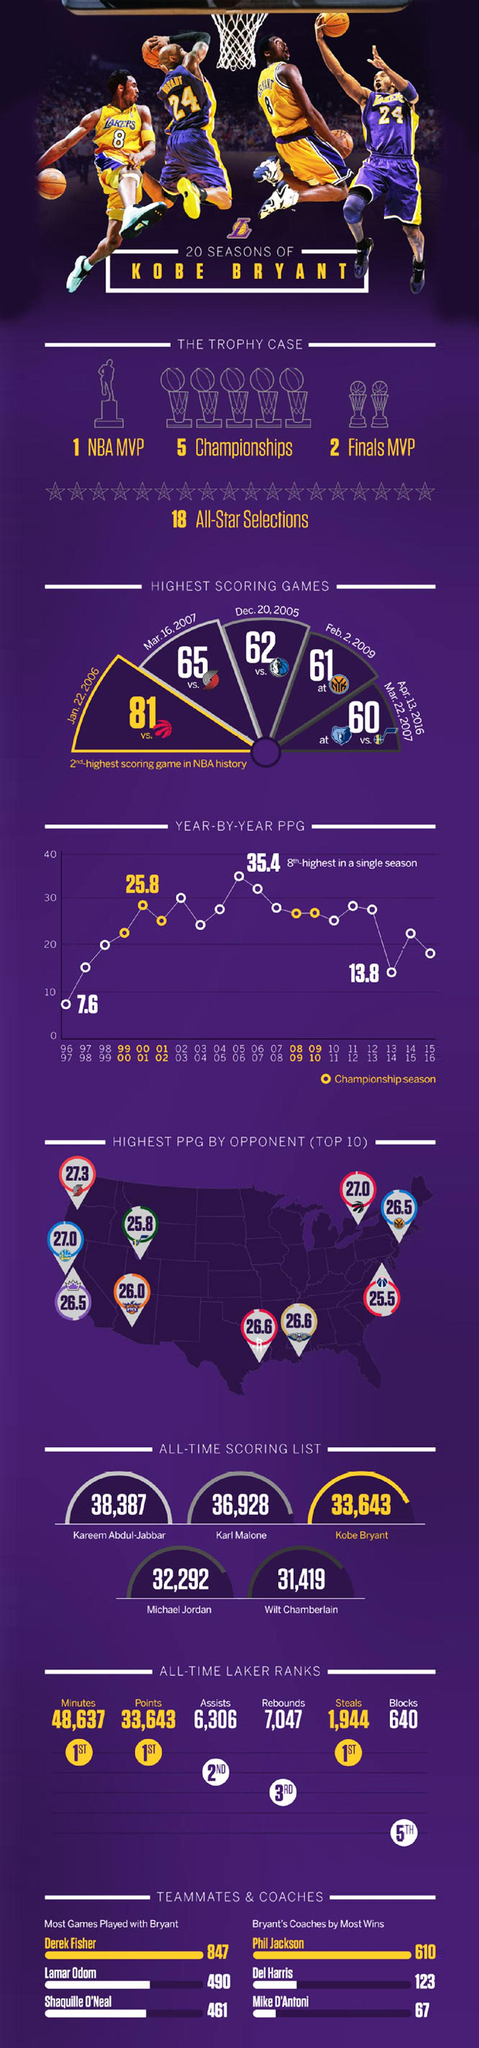Point out several critical features in this image. Kobe Bryant's coach Phil Jackson led the team to achieve the most wins throughout their time working together. Kobe Bryant won 123 games under the guidance of Dell Harris. In his illustrious career, Michael Jordan scored a total of 32,292 points, solidifying his place as one of the all-time greatest basketball players. Kobe Bryant scored a total of 33,643 points during his career, making him one of the most successful basketball players of all time. In the game played on March 16, 2007, Kobe Bryant scored a total of 65 points. 